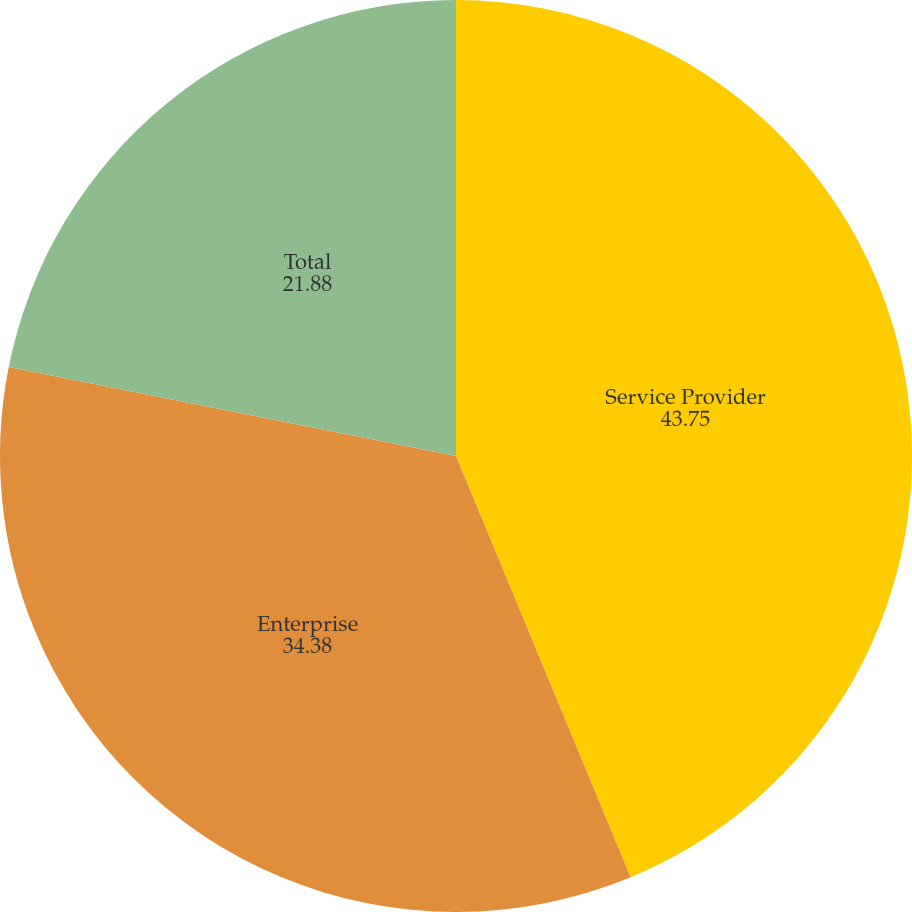<chart> <loc_0><loc_0><loc_500><loc_500><pie_chart><fcel>Service Provider<fcel>Enterprise<fcel>Total<nl><fcel>43.75%<fcel>34.38%<fcel>21.88%<nl></chart> 